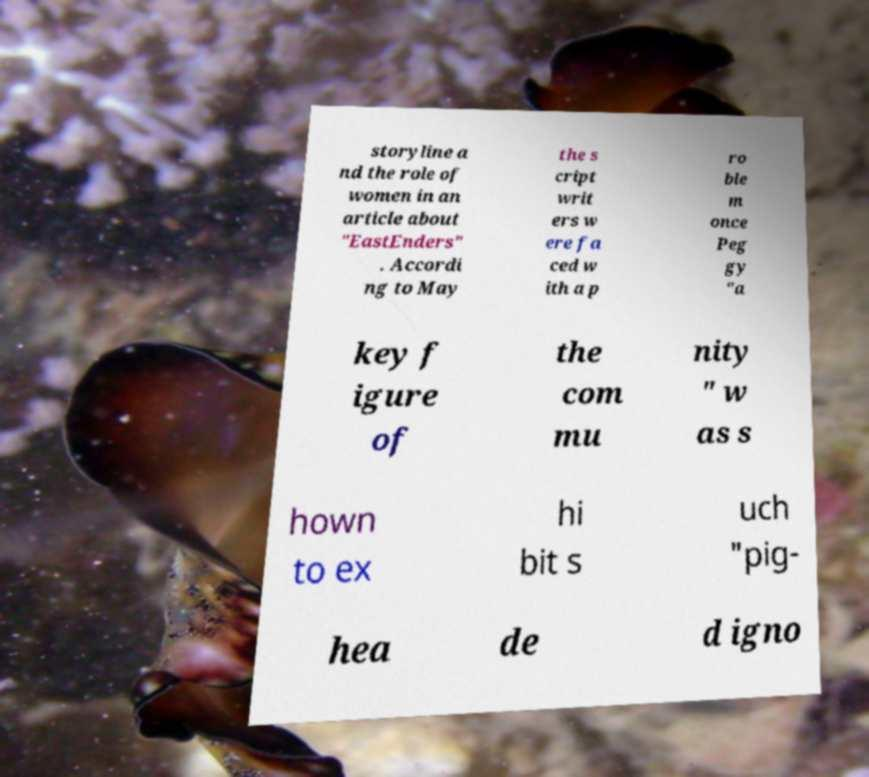Can you accurately transcribe the text from the provided image for me? storyline a nd the role of women in an article about "EastEnders" . Accordi ng to May the s cript writ ers w ere fa ced w ith a p ro ble m once Peg gy "a key f igure of the com mu nity " w as s hown to ex hi bit s uch "pig- hea de d igno 